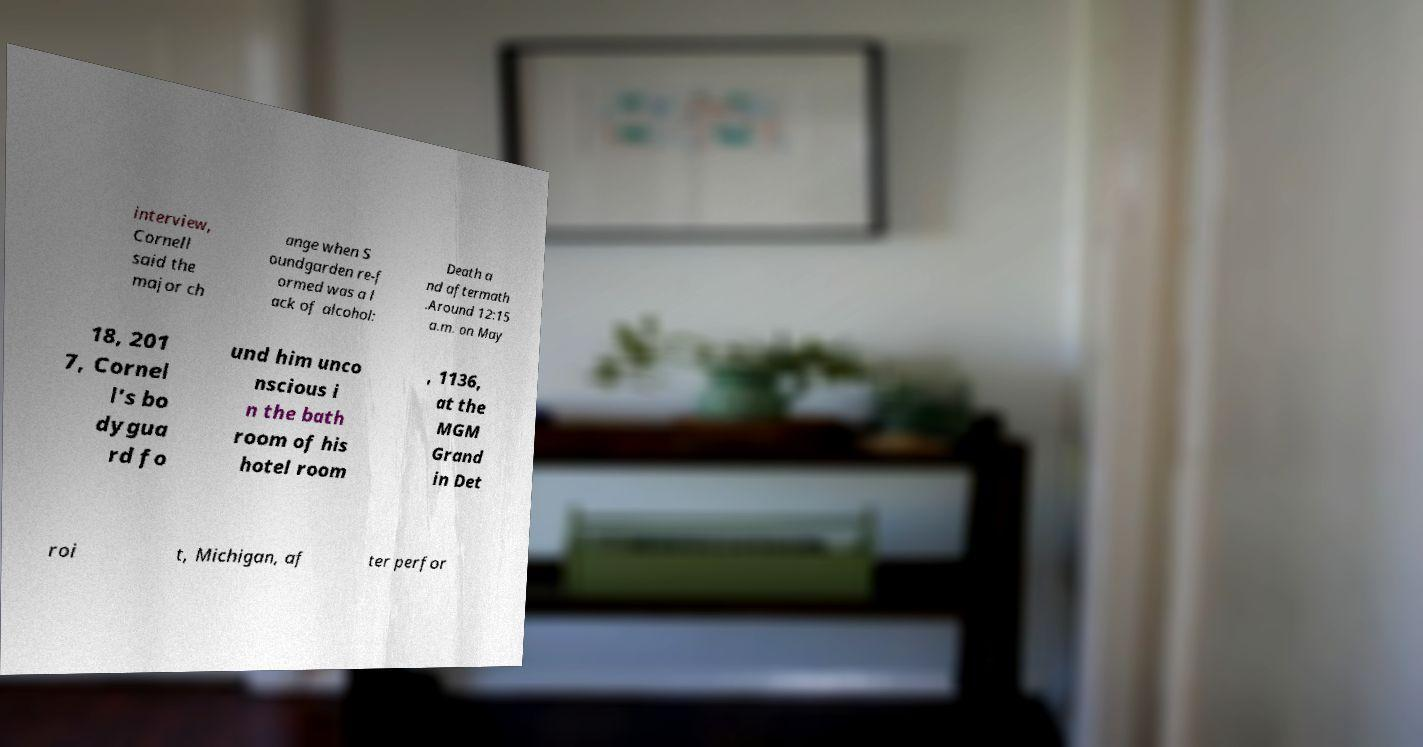What messages or text are displayed in this image? I need them in a readable, typed format. interview, Cornell said the major ch ange when S oundgarden re-f ormed was a l ack of alcohol: Death a nd aftermath .Around 12:15 a.m. on May 18, 201 7, Cornel l's bo dygua rd fo und him unco nscious i n the bath room of his hotel room , 1136, at the MGM Grand in Det roi t, Michigan, af ter perfor 